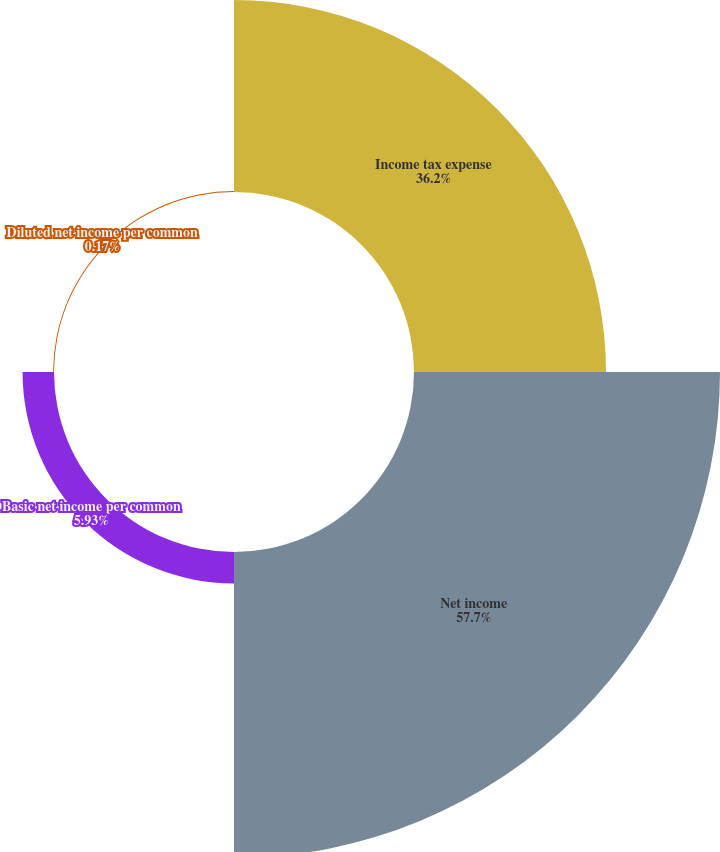<chart> <loc_0><loc_0><loc_500><loc_500><pie_chart><fcel>Income tax expense<fcel>Net income<fcel>Basic net income per common<fcel>Diluted net income per common<nl><fcel>36.2%<fcel>57.7%<fcel>5.93%<fcel>0.17%<nl></chart> 